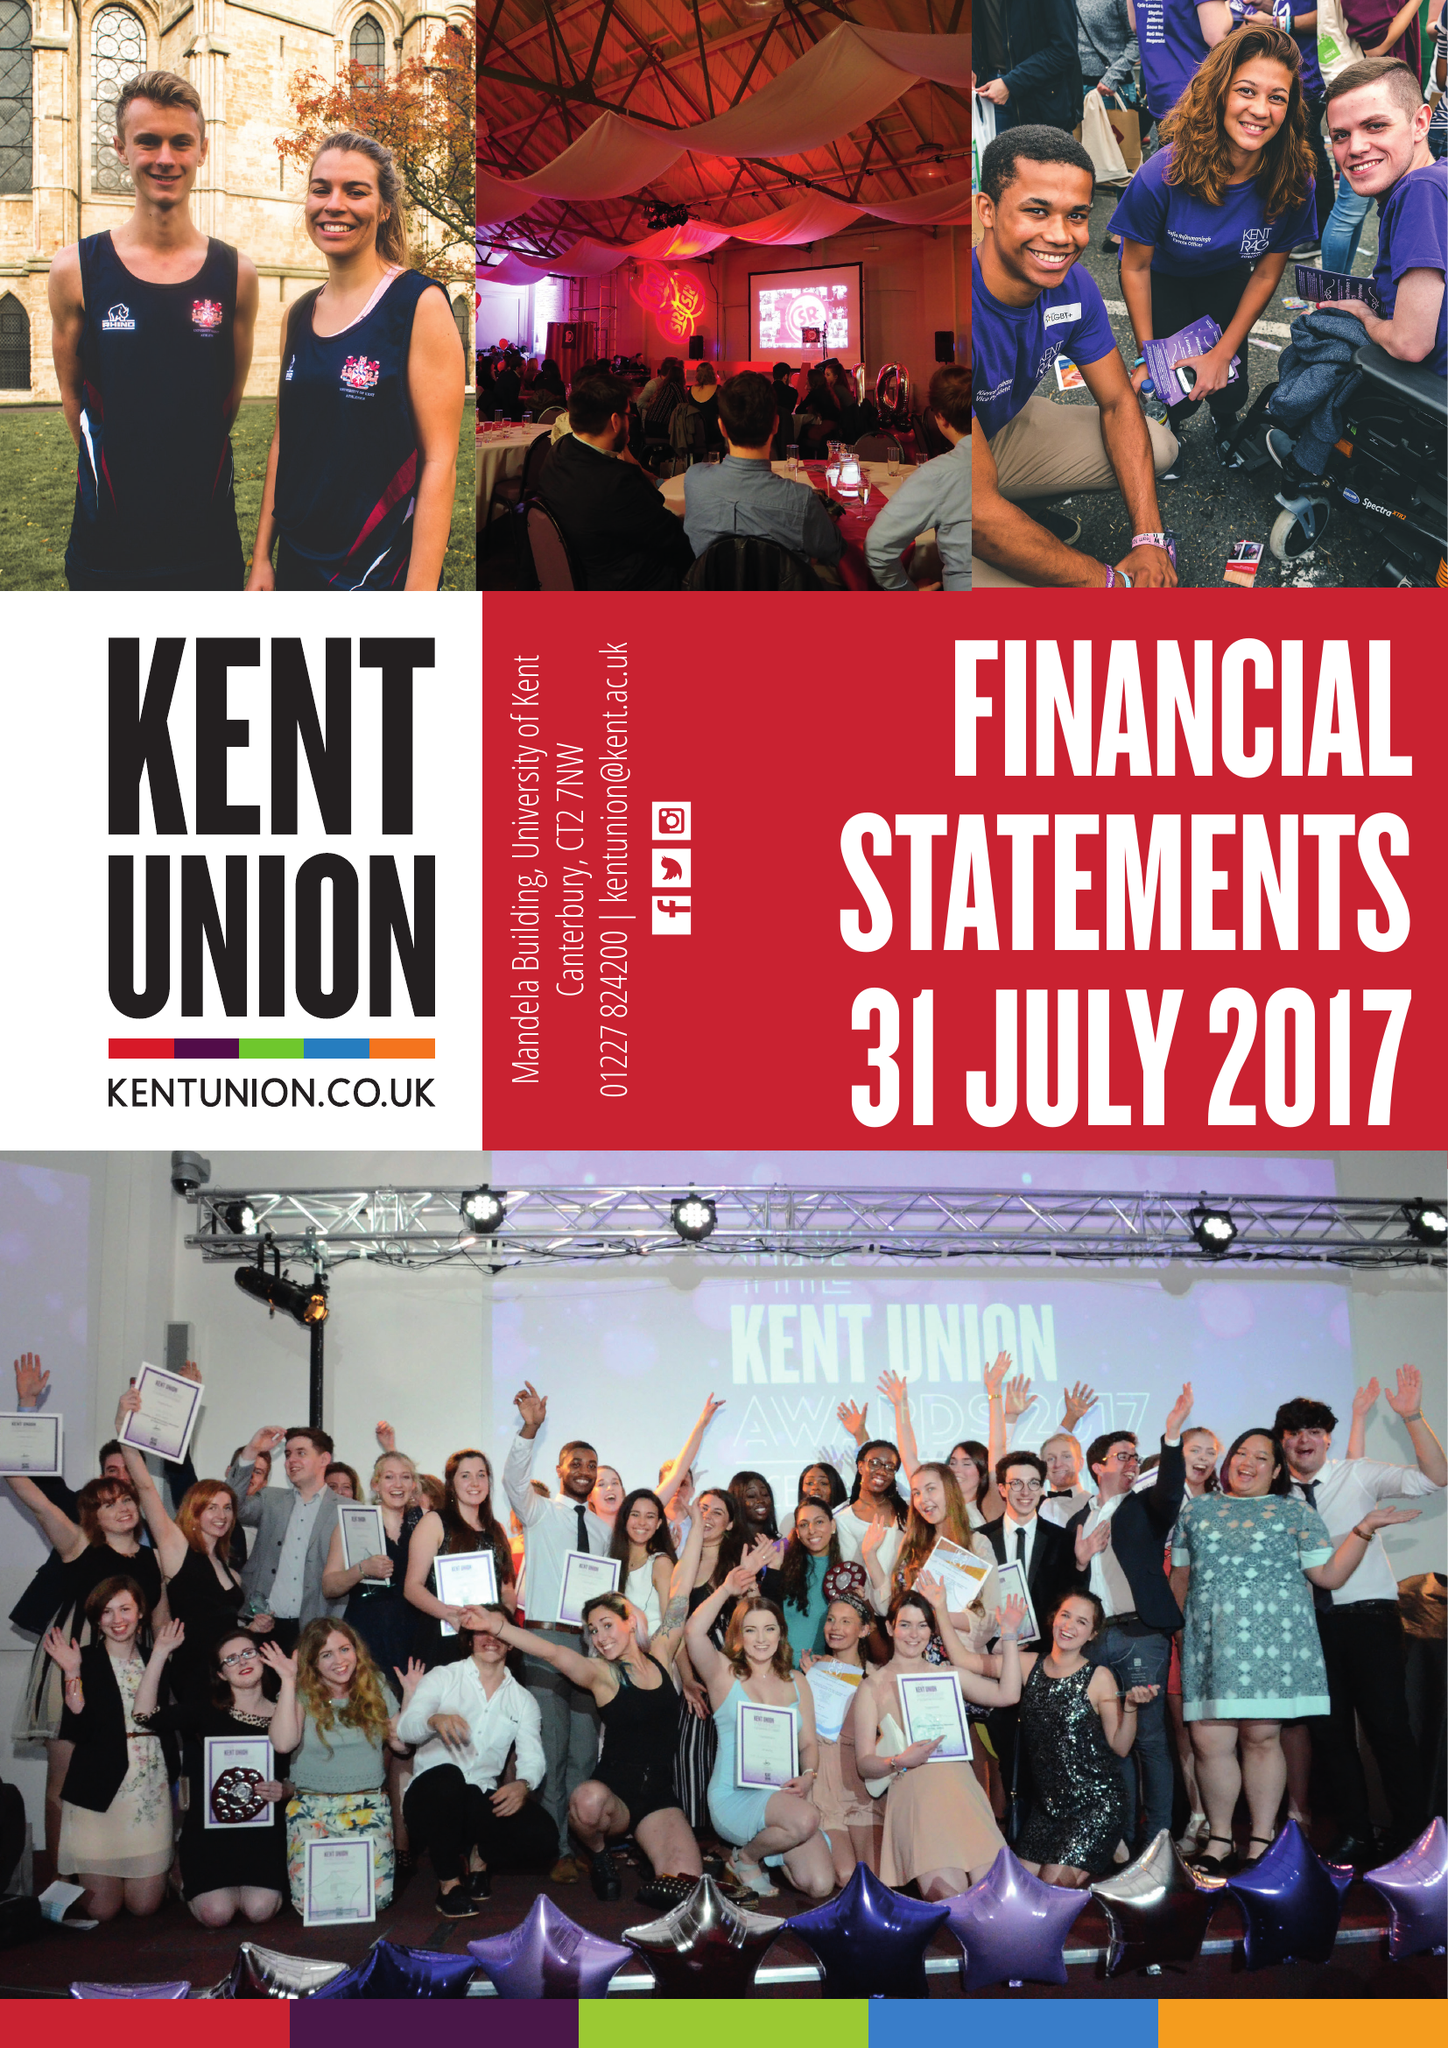What is the value for the address__post_town?
Answer the question using a single word or phrase. CANTERBURY 